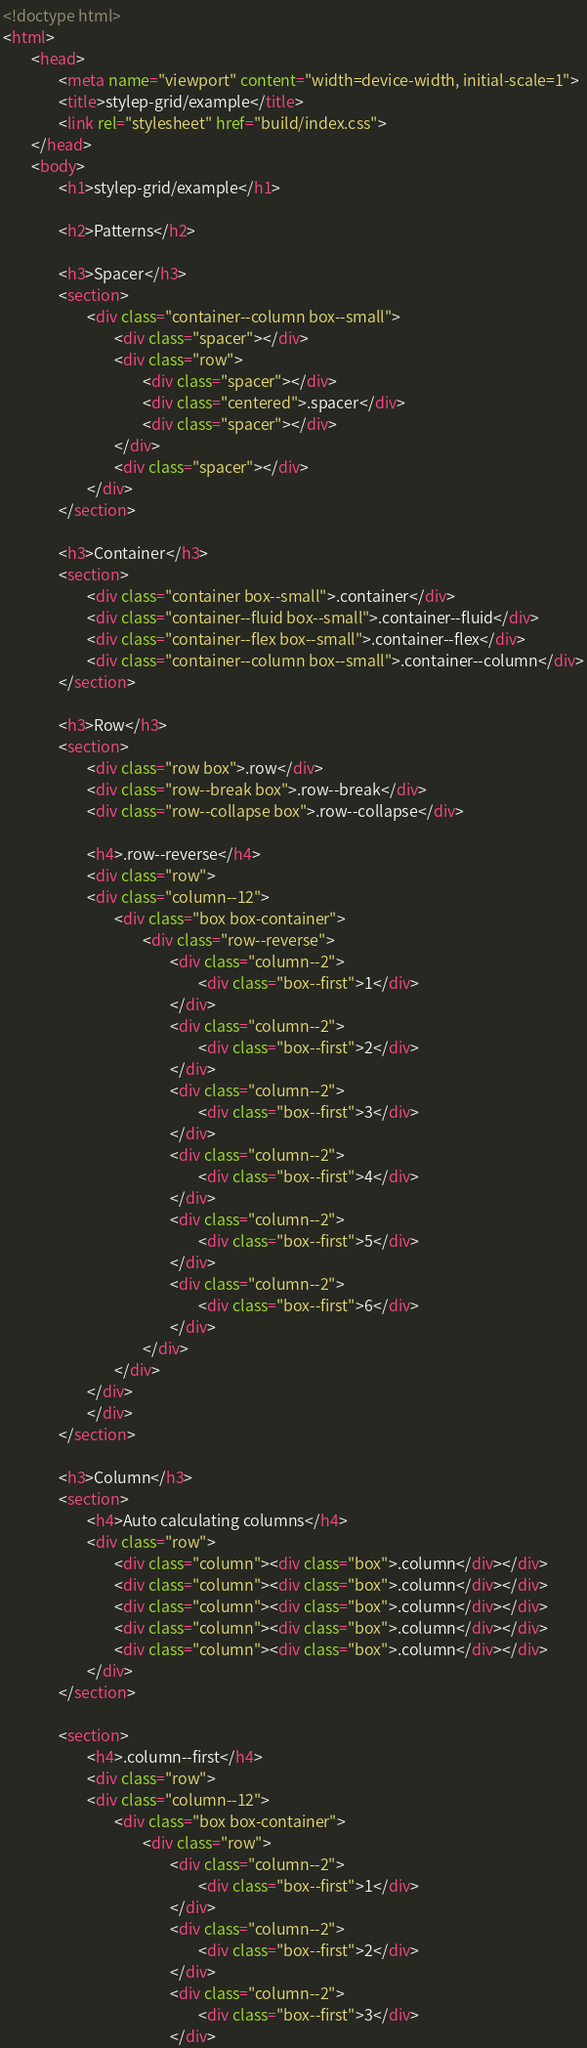<code> <loc_0><loc_0><loc_500><loc_500><_HTML_><!doctype html>
<html>
        <head>
                <meta name="viewport" content="width=device-width, initial-scale=1">
                <title>stylep-grid/example</title>
                <link rel="stylesheet" href="build/index.css">
        </head>
        <body>
                <h1>stylep-grid/example</h1>

                <h2>Patterns</h2>

                <h3>Spacer</h3>
                <section>
                        <div class="container--column box--small">
                                <div class="spacer"></div>
                                <div class="row">
                                        <div class="spacer"></div>
                                        <div class="centered">.spacer</div>
                                        <div class="spacer"></div>
                                </div>
                                <div class="spacer"></div>
                        </div>
                </section>

                <h3>Container</h3>
                <section>
                        <div class="container box--small">.container</div>
                        <div class="container--fluid box--small">.container--fluid</div>
                        <div class="container--flex box--small">.container--flex</div>
                        <div class="container--column box--small">.container--column</div>
                </section>

                <h3>Row</h3>
                <section>
                        <div class="row box">.row</div>
                        <div class="row--break box">.row--break</div>
                        <div class="row--collapse box">.row--collapse</div>

                        <h4>.row--reverse</h4>
                        <div class="row">
                        <div class="column--12">
                                <div class="box box-container">
                                        <div class="row--reverse">
                                                <div class="column--2">
                                                        <div class="box--first">1</div>
                                                </div>
                                                <div class="column--2">
                                                        <div class="box--first">2</div>
                                                </div>
                                                <div class="column--2">
                                                        <div class="box--first">3</div>
                                                </div>
                                                <div class="column--2">
                                                        <div class="box--first">4</div>
                                                </div>
                                                <div class="column--2">
                                                        <div class="box--first">5</div>
                                                </div>
                                                <div class="column--2">
                                                        <div class="box--first">6</div>
                                                </div>
                                        </div>
                                </div>
                        </div>
                        </div>
                </section>

                <h3>Column</h3>
                <section>
                        <h4>Auto calculating columns</h4>
                        <div class="row">
                                <div class="column"><div class="box">.column</div></div>
                                <div class="column"><div class="box">.column</div></div>
                                <div class="column"><div class="box">.column</div></div>
                                <div class="column"><div class="box">.column</div></div>
                                <div class="column"><div class="box">.column</div></div>
                        </div>
                </section>

                <section>
                        <h4>.column--first</h4>
                        <div class="row">
                        <div class="column--12">
                                <div class="box box-container">
                                        <div class="row">
                                                <div class="column--2">
                                                        <div class="box--first">1</div>
                                                </div>
                                                <div class="column--2">
                                                        <div class="box--first">2</div>
                                                </div>
                                                <div class="column--2">
                                                        <div class="box--first">3</div>
                                                </div></code> 